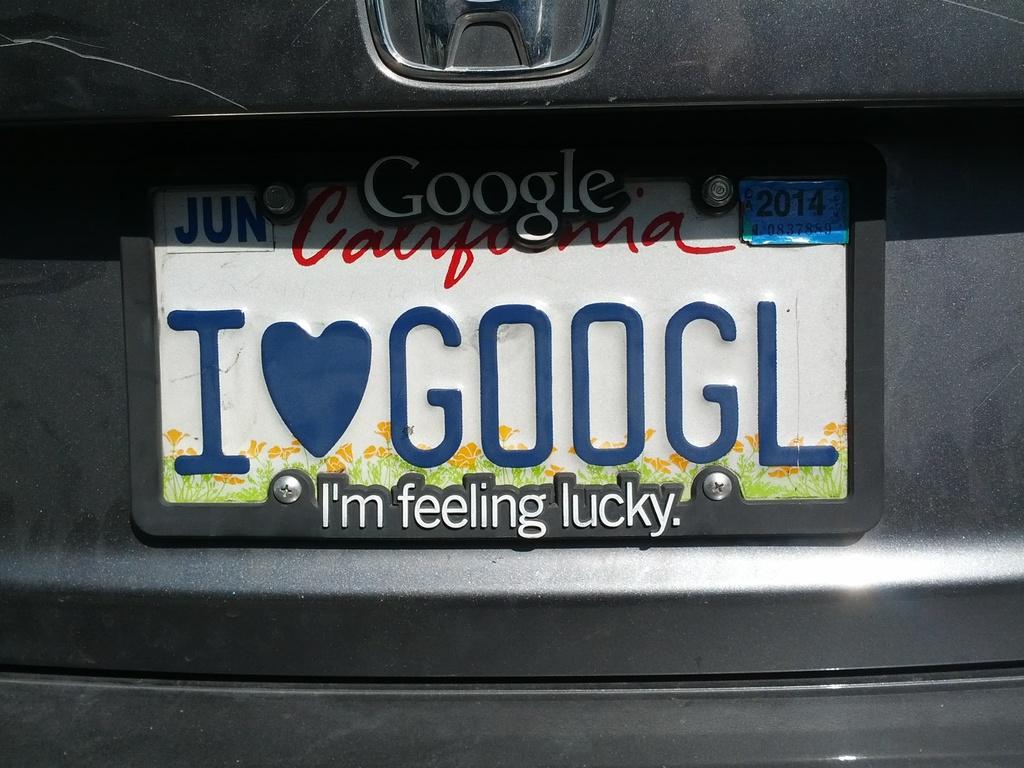What brand is advertised on the top part of the license plate?
Provide a succinct answer. Google. 